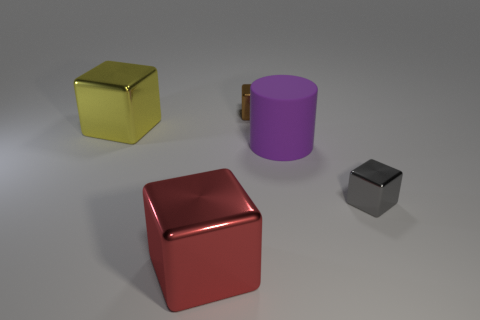Subtract all large red shiny cubes. How many cubes are left? 3 Add 2 small gray blocks. How many objects exist? 7 Subtract all yellow blocks. How many blocks are left? 3 Subtract 1 blocks. How many blocks are left? 3 Subtract all cubes. How many objects are left? 1 Add 5 tiny red metal cubes. How many tiny red metal cubes exist? 5 Subtract 0 cyan blocks. How many objects are left? 5 Subtract all red cubes. Subtract all cyan spheres. How many cubes are left? 3 Subtract all purple cylinders. Subtract all big purple matte cylinders. How many objects are left? 3 Add 5 big yellow shiny blocks. How many big yellow shiny blocks are left? 6 